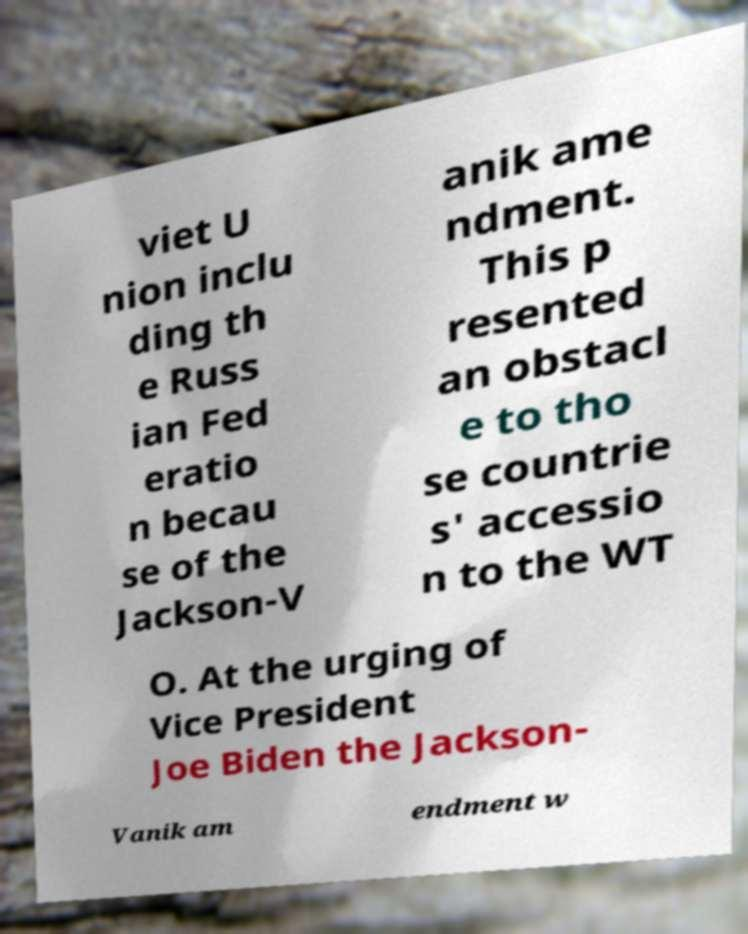For documentation purposes, I need the text within this image transcribed. Could you provide that? viet U nion inclu ding th e Russ ian Fed eratio n becau se of the Jackson-V anik ame ndment. This p resented an obstacl e to tho se countrie s' accessio n to the WT O. At the urging of Vice President Joe Biden the Jackson- Vanik am endment w 